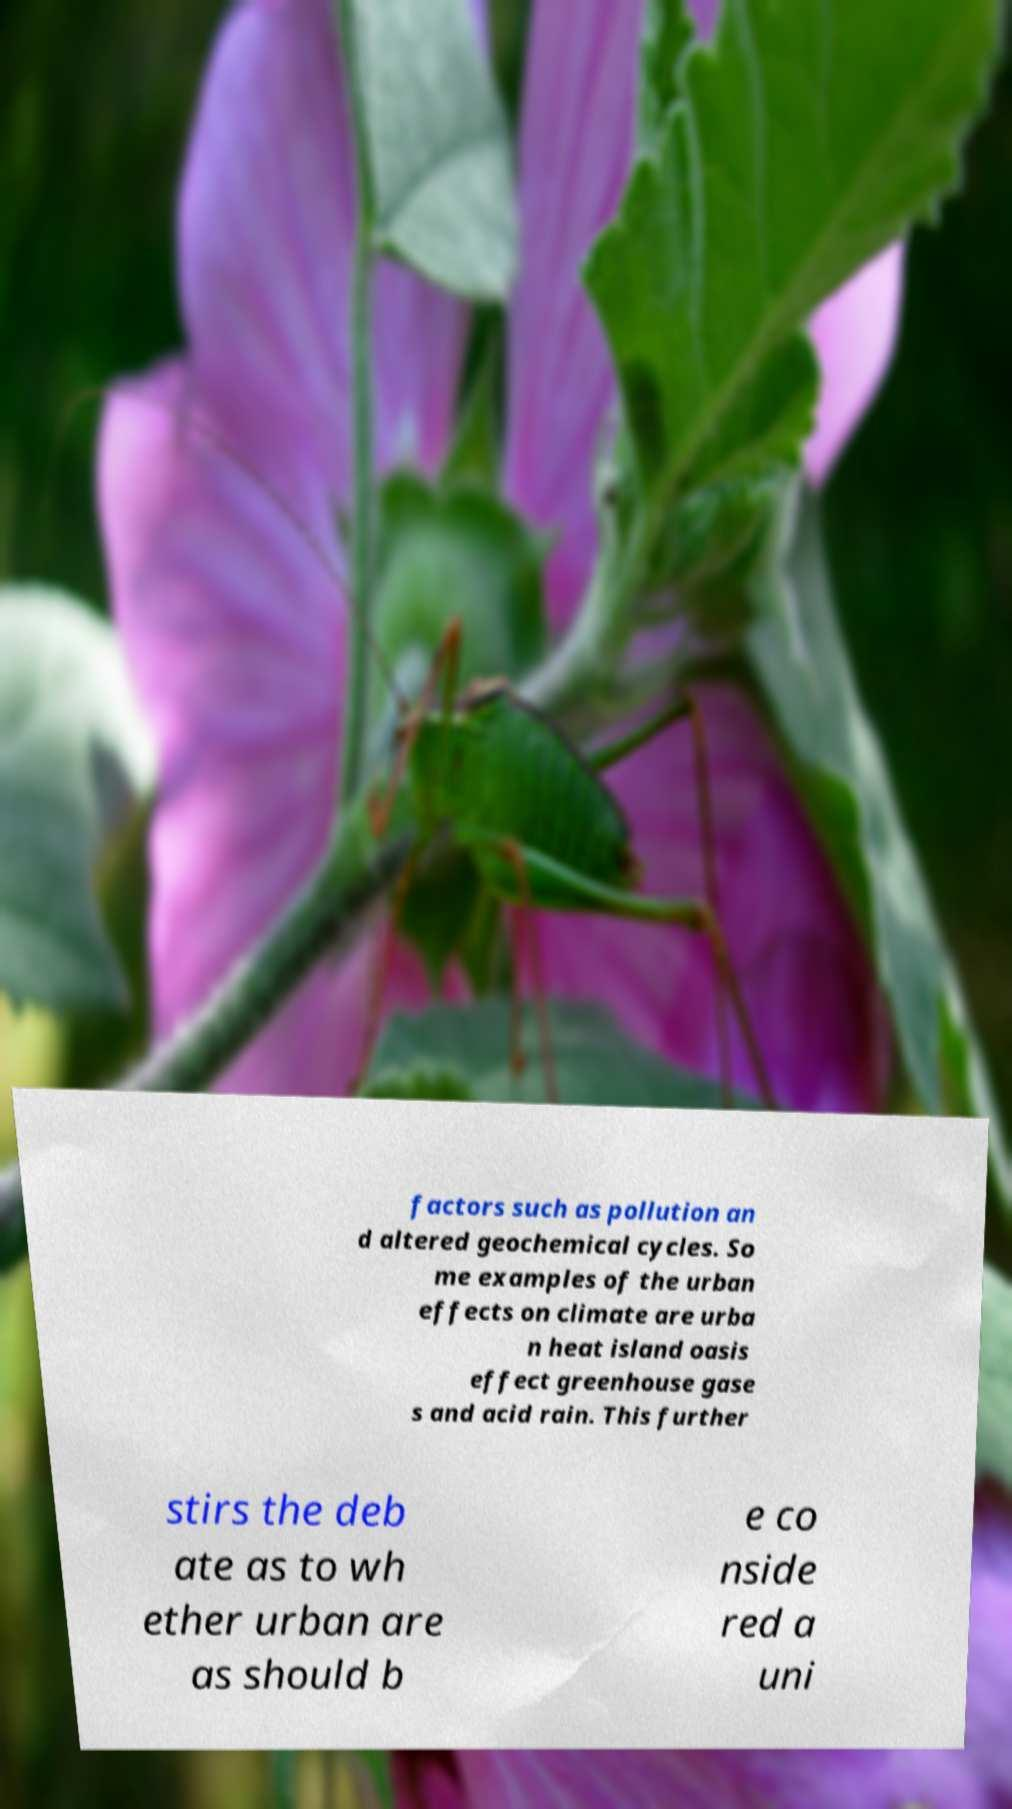What messages or text are displayed in this image? I need them in a readable, typed format. factors such as pollution an d altered geochemical cycles. So me examples of the urban effects on climate are urba n heat island oasis effect greenhouse gase s and acid rain. This further stirs the deb ate as to wh ether urban are as should b e co nside red a uni 